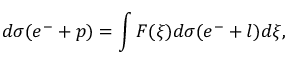Convert formula to latex. <formula><loc_0><loc_0><loc_500><loc_500>d \sigma ( e ^ { - } + p ) = \int F ( \xi ) d \sigma ( e ^ { - } + l ) d \xi ,</formula> 